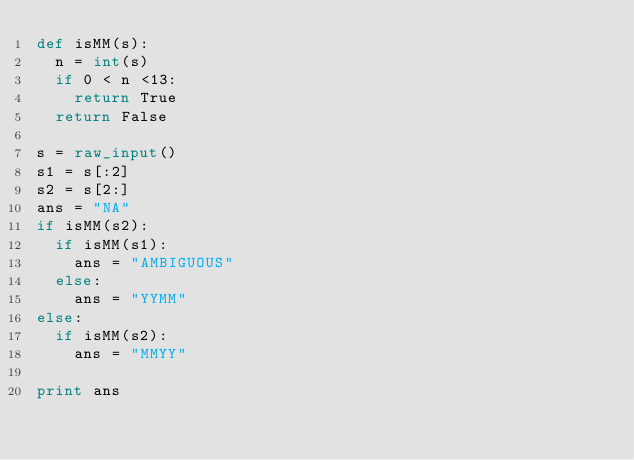Convert code to text. <code><loc_0><loc_0><loc_500><loc_500><_Python_>def isMM(s):
  n = int(s)
  if 0 < n <13:
    return True
  return False

s = raw_input()
s1 = s[:2]
s2 = s[2:]
ans = "NA"
if isMM(s2):
  if isMM(s1):
    ans = "AMBIGUOUS"
  else:
    ans = "YYMM"
else:
  if isMM(s2):
    ans = "MMYY"
    
print ans</code> 